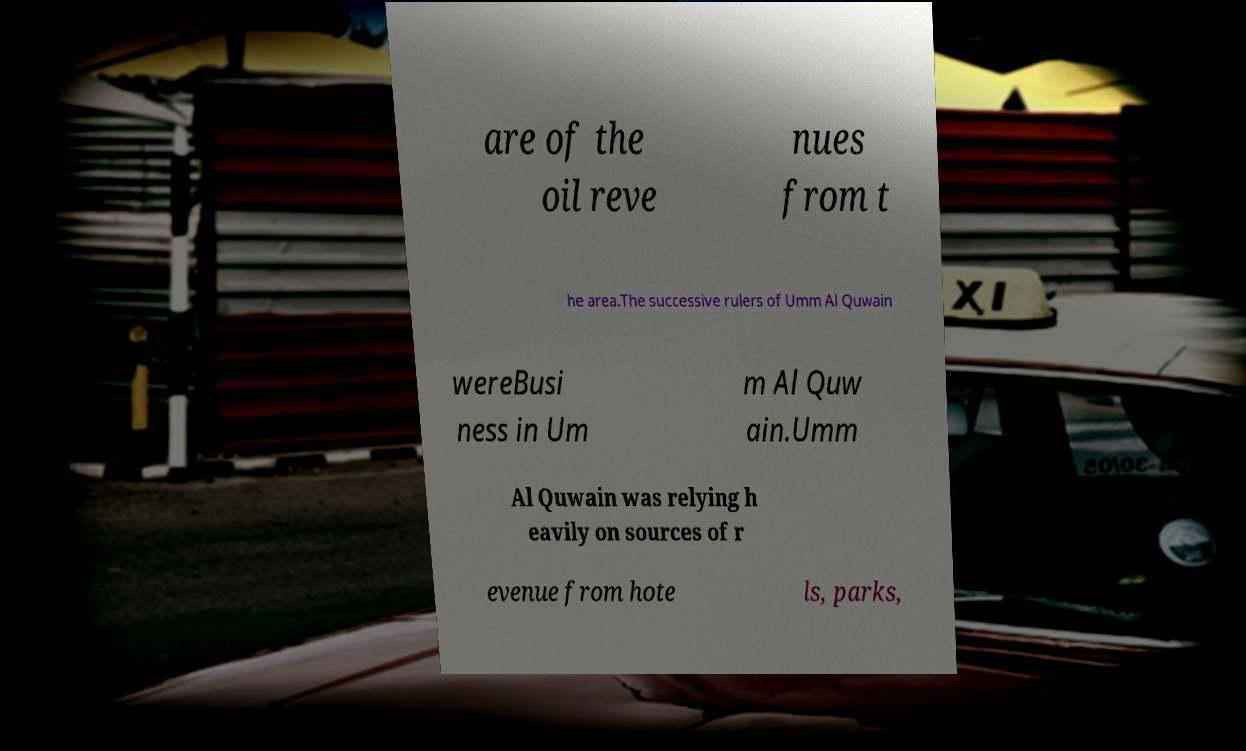Can you read and provide the text displayed in the image?This photo seems to have some interesting text. Can you extract and type it out for me? are of the oil reve nues from t he area.The successive rulers of Umm Al Quwain wereBusi ness in Um m Al Quw ain.Umm Al Quwain was relying h eavily on sources of r evenue from hote ls, parks, 